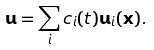Convert formula to latex. <formula><loc_0><loc_0><loc_500><loc_500>\mathbf u = \sum _ { i } c _ { i } ( t ) \mathbf u _ { i } ( \mathbf x ) .</formula> 